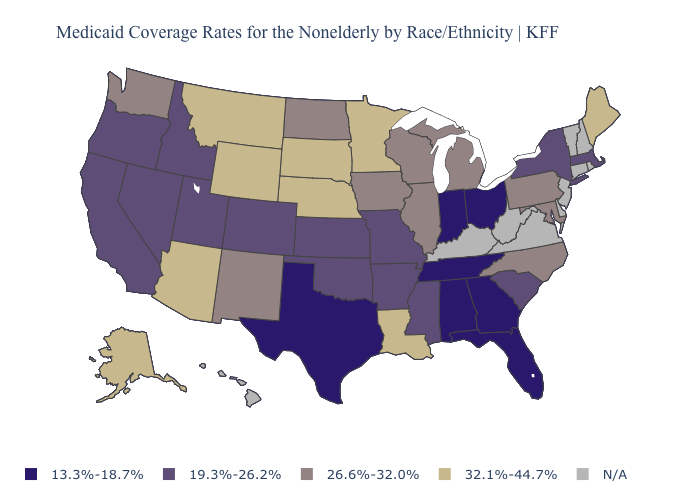Name the states that have a value in the range 26.6%-32.0%?
Answer briefly. Illinois, Iowa, Maryland, Michigan, New Mexico, North Carolina, North Dakota, Pennsylvania, Washington, Wisconsin. How many symbols are there in the legend?
Concise answer only. 5. Does Wyoming have the highest value in the USA?
Answer briefly. Yes. What is the value of Minnesota?
Write a very short answer. 32.1%-44.7%. What is the highest value in the USA?
Keep it brief. 32.1%-44.7%. What is the value of Alabama?
Give a very brief answer. 13.3%-18.7%. What is the value of Missouri?
Give a very brief answer. 19.3%-26.2%. Which states have the lowest value in the USA?
Give a very brief answer. Alabama, Florida, Georgia, Indiana, Ohio, Tennessee, Texas. How many symbols are there in the legend?
Write a very short answer. 5. How many symbols are there in the legend?
Give a very brief answer. 5. Does Illinois have the highest value in the MidWest?
Write a very short answer. No. Among the states that border Louisiana , does Arkansas have the highest value?
Concise answer only. Yes. How many symbols are there in the legend?
Short answer required. 5. Name the states that have a value in the range 32.1%-44.7%?
Keep it brief. Alaska, Arizona, Louisiana, Maine, Minnesota, Montana, Nebraska, South Dakota, Wyoming. 